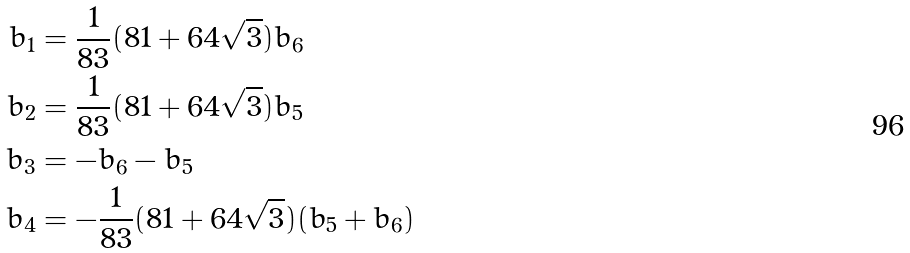<formula> <loc_0><loc_0><loc_500><loc_500>b _ { 1 } & = \frac { 1 } { 8 3 } ( 8 1 + 6 4 \sqrt { 3 } ) b _ { 6 } \\ b _ { 2 } & = \frac { 1 } { 8 3 } ( 8 1 + 6 4 \sqrt { 3 } ) b _ { 5 } \\ b _ { 3 } & = - b _ { 6 } - b _ { 5 } \\ b _ { 4 } & = - \frac { 1 } { 8 3 } ( 8 1 + 6 4 \sqrt { 3 } ) ( b _ { 5 } + b _ { 6 } )</formula> 